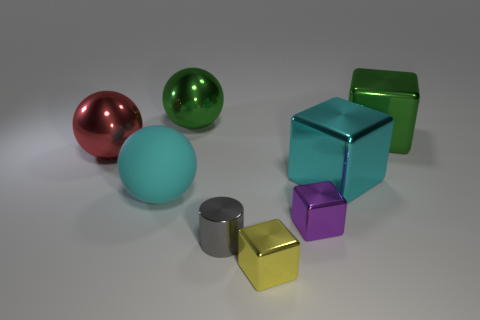What is the material of the green sphere that is the same size as the red ball?
Offer a terse response. Metal. Are there any tiny purple shiny objects to the left of the cyan object in front of the big cyan metallic object?
Offer a terse response. No. How many other things are there of the same color as the metallic cylinder?
Provide a succinct answer. 0. What size is the green metal block?
Make the answer very short. Large. Is there a large yellow metallic ball?
Offer a very short reply. No. Is the number of big red things that are to the right of the large green sphere greater than the number of large shiny things right of the large cyan metal block?
Keep it short and to the point. No. There is a large object that is both in front of the red object and to the left of the gray cylinder; what material is it?
Provide a succinct answer. Rubber. Is the large cyan metallic object the same shape as the large red thing?
Provide a succinct answer. No. Are there any other things that have the same size as the gray metallic thing?
Your answer should be very brief. Yes. What number of cylinders are behind the rubber object?
Offer a terse response. 0. 